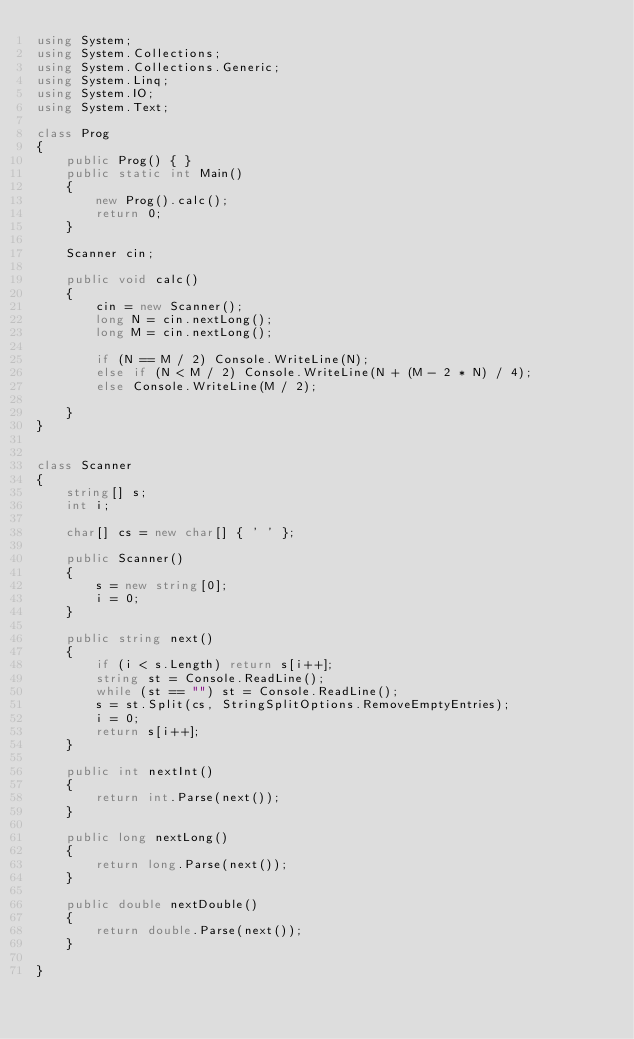<code> <loc_0><loc_0><loc_500><loc_500><_C#_>using System;
using System.Collections;
using System.Collections.Generic;
using System.Linq;
using System.IO;
using System.Text;

class Prog
{
    public Prog() { }
    public static int Main()
    {
        new Prog().calc();
        return 0;
    }

    Scanner cin;

    public void calc()
    {
        cin = new Scanner();
        long N = cin.nextLong();
        long M = cin.nextLong();

        if (N == M / 2) Console.WriteLine(N);
        else if (N < M / 2) Console.WriteLine(N + (M - 2 * N) / 4);
        else Console.WriteLine(M / 2);

    }
}


class Scanner
{
    string[] s;
    int i;

    char[] cs = new char[] { ' ' };

    public Scanner()
    {
        s = new string[0];
        i = 0;
    }

    public string next()
    {
        if (i < s.Length) return s[i++];
        string st = Console.ReadLine();
        while (st == "") st = Console.ReadLine();
        s = st.Split(cs, StringSplitOptions.RemoveEmptyEntries);
        i = 0;
        return s[i++];
    }

    public int nextInt()
    {
        return int.Parse(next());
    }

    public long nextLong()
    {
        return long.Parse(next());
    }

    public double nextDouble()
    {
        return double.Parse(next());
    }

}</code> 